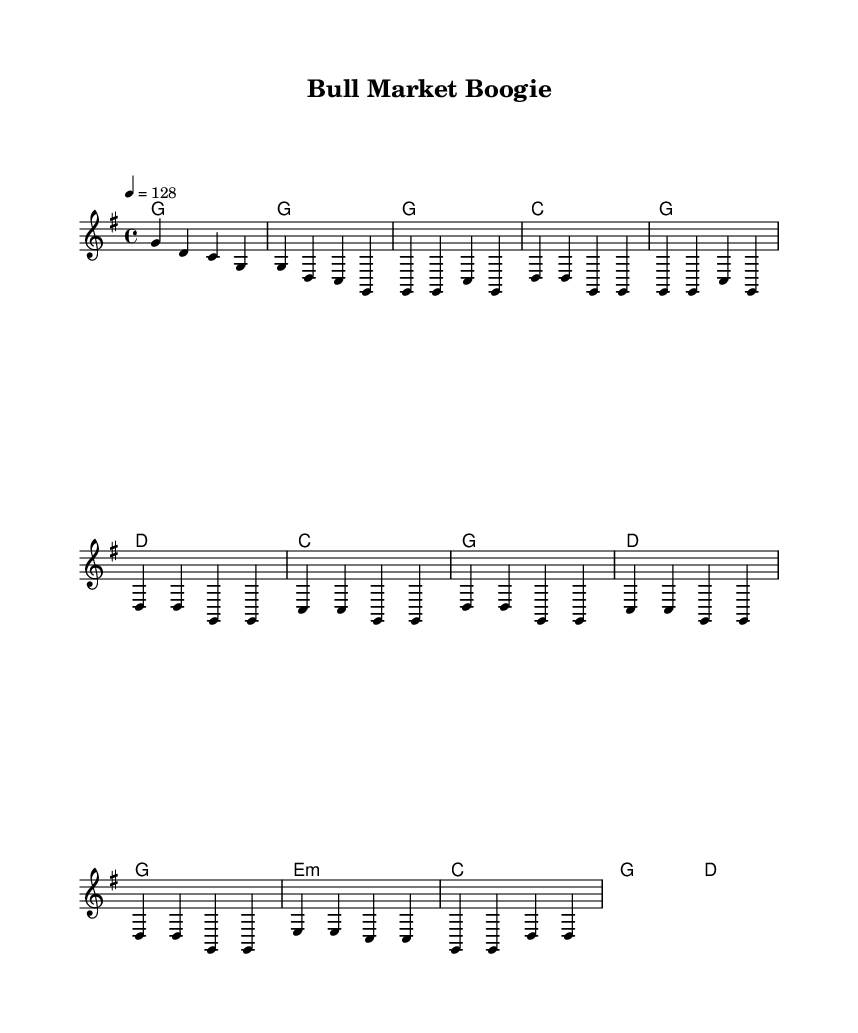What is the key signature of this music? The key signature is G major, which has one sharp (F#). This can be identified from the global setting in the code that specifies "\key g \major" at the beginning.
Answer: G major What is the time signature of this music? The time signature is 4/4, indicated by the "\time 4/4" notation in the global section of the code. This means there are four beats per measure and a quarter note receives one beat.
Answer: 4/4 What is the tempo marking for this piece? The tempo marking is 128 beats per minute, which is provided by the "\tempo 4 = 128" setting in the global section. This indicates the speed at which the piece should be played.
Answer: 128 What phrase describes the chorus of the song? The chorus features the phrases "It's a bull market boogie, let the good times roll" and "Watchin' those numbers climb, it's good for the soul." These phrases are presented in the chorusWords section of the code, as indicated by the corresponding lyric indication in the score.
Answer: Bull market boogie How many measures are there in the verse? The verse contains eight measures. This can be counted from the melody section where there are four groupings of four beats each, and visually from the score when looking at the sections designated for the verse in the music notation.
Answer: Eight measures What musical section follows the verse? The section that follows the verse is the chorus. This is structured in the code where the verse is defined, followed by a separate section for the chorus with distinct lyrics and melodies.
Answer: Chorus What instrumentation is indicated in this score? The instrumentation indicated in the score consists of a staff for the melody and chord names for the harmonies. There is no specific instrumentation mentioned, but the structure suggests it is likely for a typical country band arrangement including vocals.
Answer: Staff and chords 